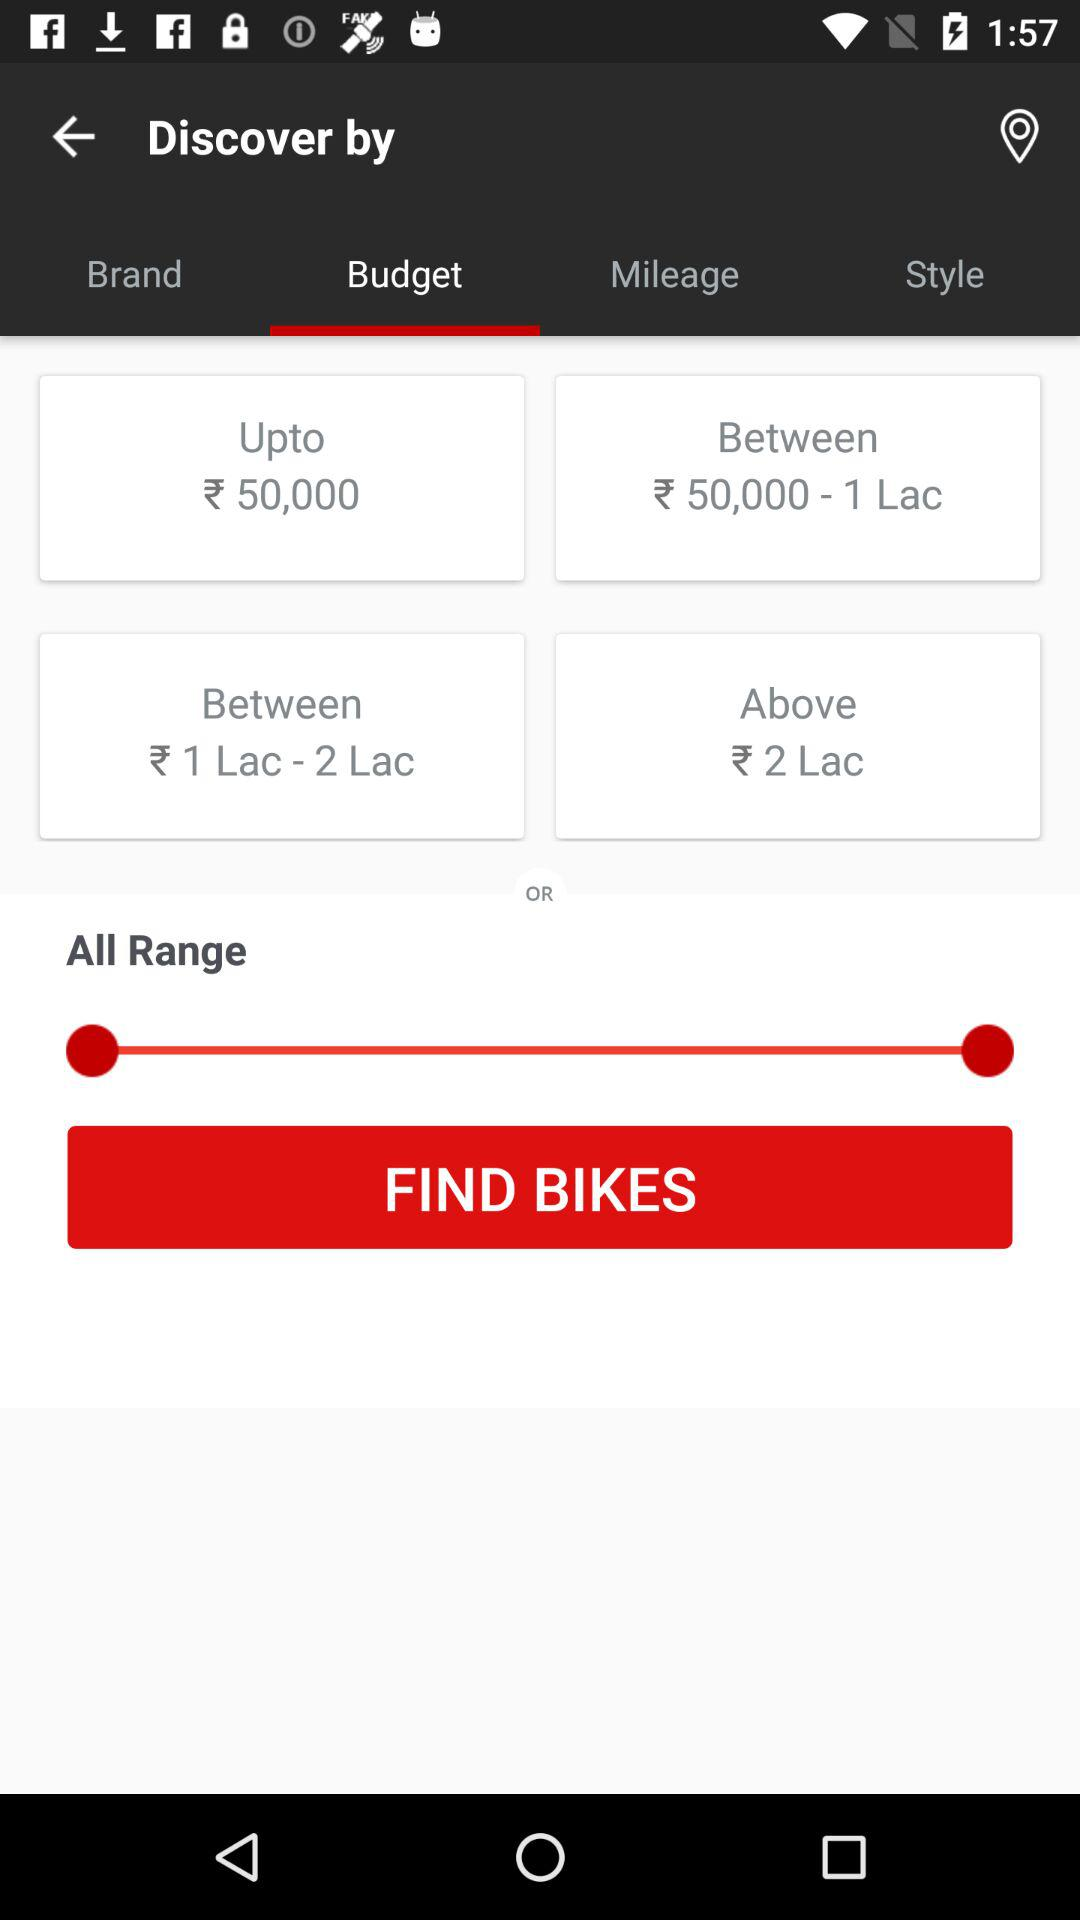How many budget options are available?
Answer the question using a single word or phrase. 4 